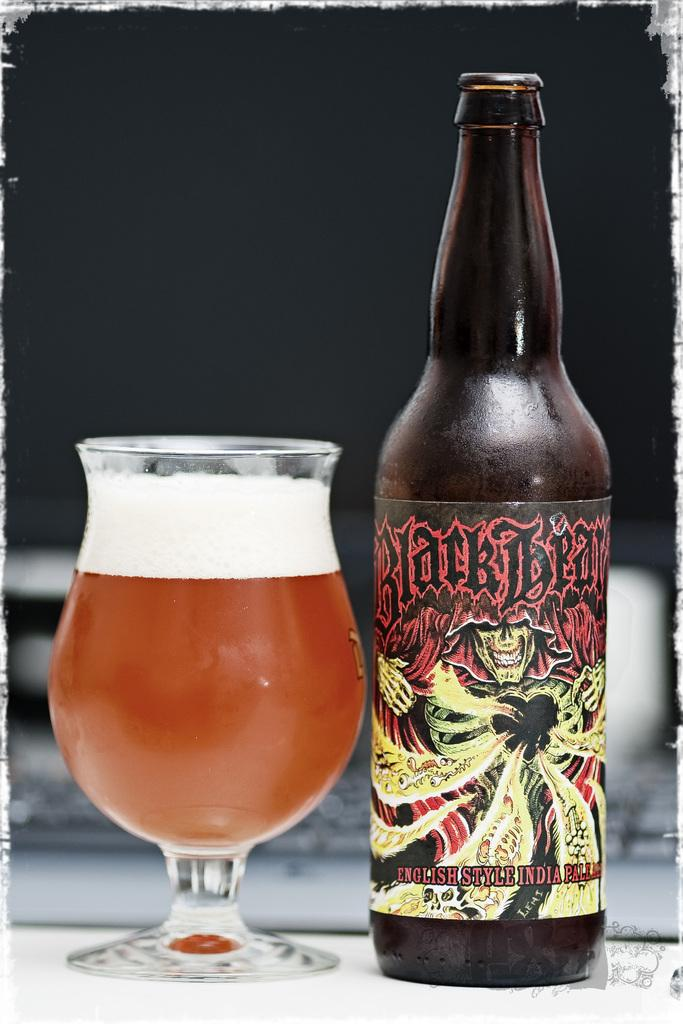Provide a one-sentence caption for the provided image. Bottle of Blackbeard English Style Pale Ale beside a full glass. 